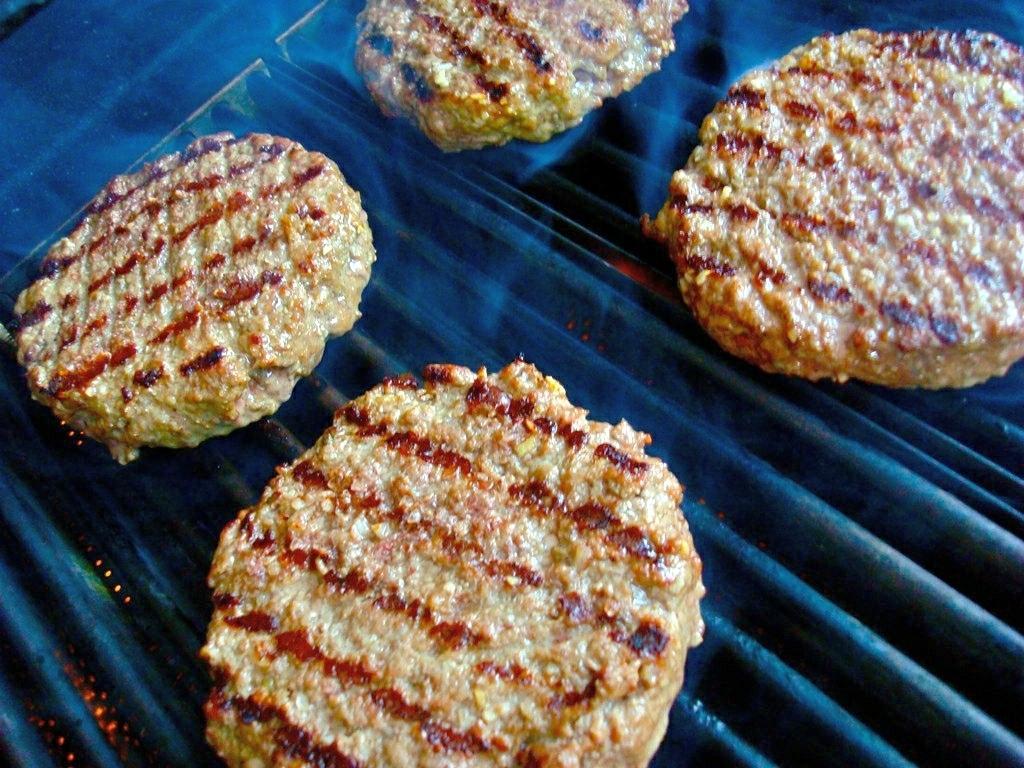Could you give a brief overview of what you see in this image? This image consists of food item. At the bottom, there is a grill. 